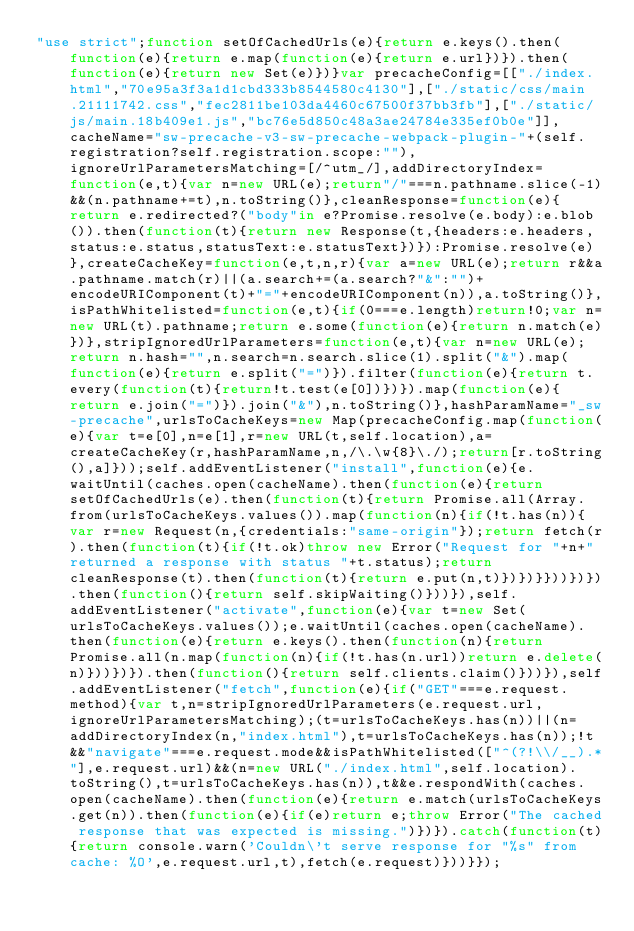<code> <loc_0><loc_0><loc_500><loc_500><_JavaScript_>"use strict";function setOfCachedUrls(e){return e.keys().then(function(e){return e.map(function(e){return e.url})}).then(function(e){return new Set(e)})}var precacheConfig=[["./index.html","70e95a3f3a1d1cbd333b8544580c4130"],["./static/css/main.21111742.css","fec2811be103da4460c67500f37bb3fb"],["./static/js/main.18b409e1.js","bc76e5d850c48a3ae24784e335ef0b0e"]],cacheName="sw-precache-v3-sw-precache-webpack-plugin-"+(self.registration?self.registration.scope:""),ignoreUrlParametersMatching=[/^utm_/],addDirectoryIndex=function(e,t){var n=new URL(e);return"/"===n.pathname.slice(-1)&&(n.pathname+=t),n.toString()},cleanResponse=function(e){return e.redirected?("body"in e?Promise.resolve(e.body):e.blob()).then(function(t){return new Response(t,{headers:e.headers,status:e.status,statusText:e.statusText})}):Promise.resolve(e)},createCacheKey=function(e,t,n,r){var a=new URL(e);return r&&a.pathname.match(r)||(a.search+=(a.search?"&":"")+encodeURIComponent(t)+"="+encodeURIComponent(n)),a.toString()},isPathWhitelisted=function(e,t){if(0===e.length)return!0;var n=new URL(t).pathname;return e.some(function(e){return n.match(e)})},stripIgnoredUrlParameters=function(e,t){var n=new URL(e);return n.hash="",n.search=n.search.slice(1).split("&").map(function(e){return e.split("=")}).filter(function(e){return t.every(function(t){return!t.test(e[0])})}).map(function(e){return e.join("=")}).join("&"),n.toString()},hashParamName="_sw-precache",urlsToCacheKeys=new Map(precacheConfig.map(function(e){var t=e[0],n=e[1],r=new URL(t,self.location),a=createCacheKey(r,hashParamName,n,/\.\w{8}\./);return[r.toString(),a]}));self.addEventListener("install",function(e){e.waitUntil(caches.open(cacheName).then(function(e){return setOfCachedUrls(e).then(function(t){return Promise.all(Array.from(urlsToCacheKeys.values()).map(function(n){if(!t.has(n)){var r=new Request(n,{credentials:"same-origin"});return fetch(r).then(function(t){if(!t.ok)throw new Error("Request for "+n+" returned a response with status "+t.status);return cleanResponse(t).then(function(t){return e.put(n,t)})})}}))})}).then(function(){return self.skipWaiting()}))}),self.addEventListener("activate",function(e){var t=new Set(urlsToCacheKeys.values());e.waitUntil(caches.open(cacheName).then(function(e){return e.keys().then(function(n){return Promise.all(n.map(function(n){if(!t.has(n.url))return e.delete(n)}))})}).then(function(){return self.clients.claim()}))}),self.addEventListener("fetch",function(e){if("GET"===e.request.method){var t,n=stripIgnoredUrlParameters(e.request.url,ignoreUrlParametersMatching);(t=urlsToCacheKeys.has(n))||(n=addDirectoryIndex(n,"index.html"),t=urlsToCacheKeys.has(n));!t&&"navigate"===e.request.mode&&isPathWhitelisted(["^(?!\\/__).*"],e.request.url)&&(n=new URL("./index.html",self.location).toString(),t=urlsToCacheKeys.has(n)),t&&e.respondWith(caches.open(cacheName).then(function(e){return e.match(urlsToCacheKeys.get(n)).then(function(e){if(e)return e;throw Error("The cached response that was expected is missing.")})}).catch(function(t){return console.warn('Couldn\'t serve response for "%s" from cache: %O',e.request.url,t),fetch(e.request)}))}});</code> 